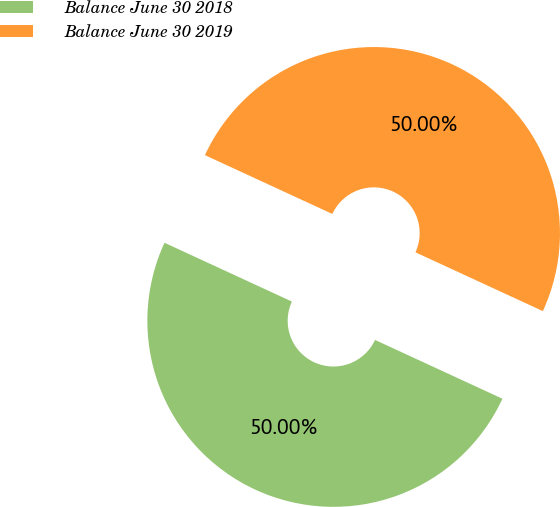Convert chart to OTSL. <chart><loc_0><loc_0><loc_500><loc_500><pie_chart><fcel>Balance June 30 2018<fcel>Balance June 30 2019<nl><fcel>50.0%<fcel>50.0%<nl></chart> 